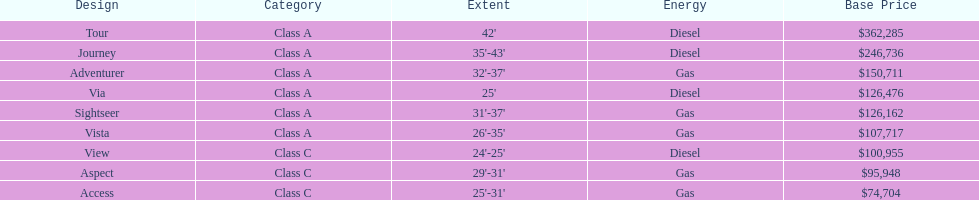Which model is at the top of the list with the highest starting price? Tour. 